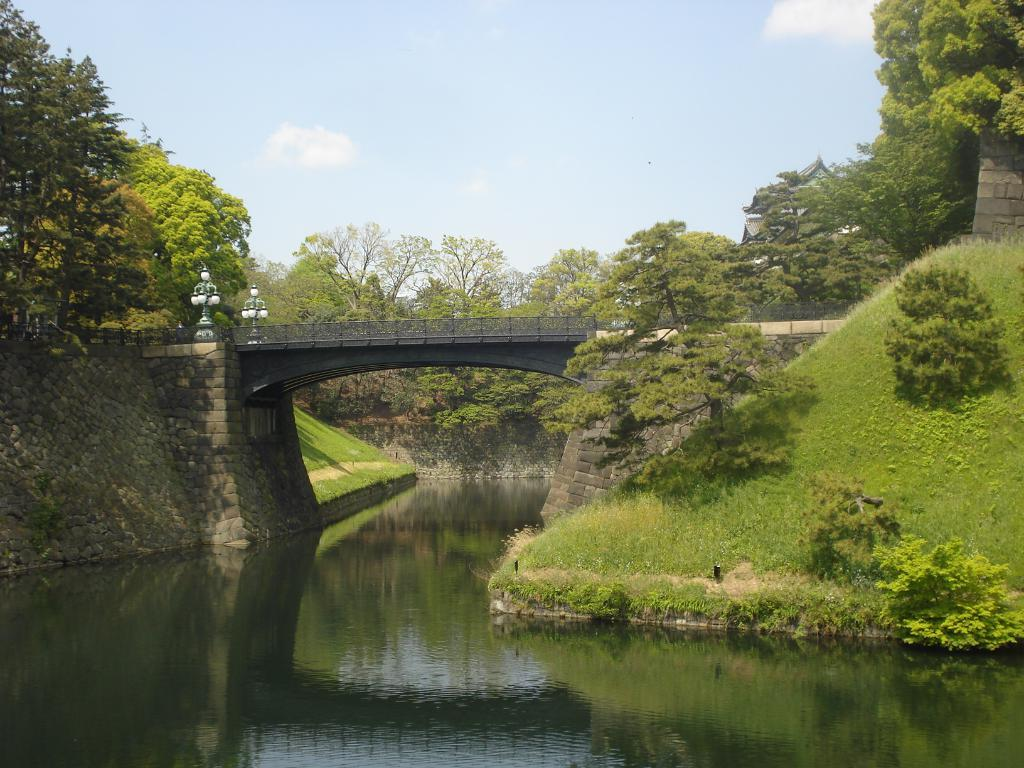What structure is present in the image? There is a bridge in the image. What is located beneath the bridge? There is a lake under the bridge. What can be seen at the top of the image? The sky is visible at the top of the image. What type of vegetation is in the middle of the image? There are trees and grass in the middle of the image. What hobbies do the sheep in the image enjoy? There are no sheep present in the image, so we cannot determine their hobbies. 